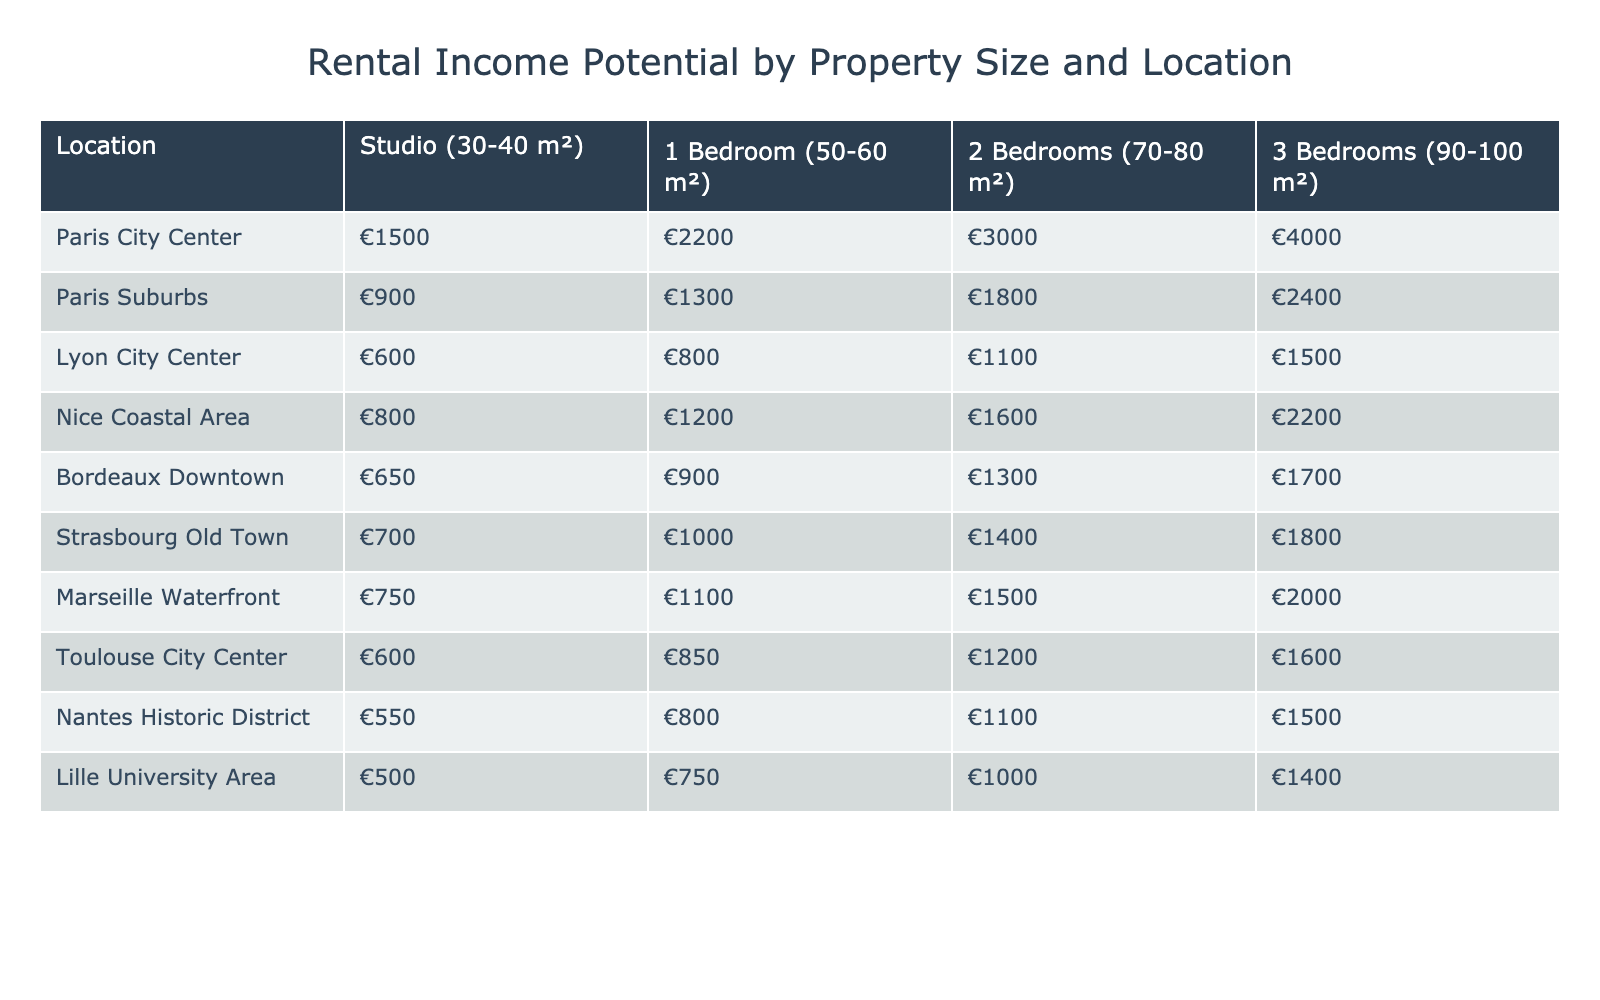What is the rental income for a 2-bedroom property in Paris City Center? The table indicates that the rental income for a 2-bedroom property (70-80 m²) in Paris City Center is listed as €3000.
Answer: €3000 Which location offers the highest rental income for a 1-bedroom property? In the table, Paris City Center shows the highest rental income for a 1-bedroom property at €2200.
Answer: Paris City Center What is the average rental income for a studio across all locations? To find the average, we sum the studio rental incomes: €1500 + €900 + €600 + €800 + €650 + €700 + €750 + €600 + €550 + €500 = €7550. There are 10 locations, so we divide: €7550 / 10 = €755.
Answer: €755 Is the rental income for a 3-bedroom property in Lyon City Center higher than in Marseille Waterfront? The rental income for a 3-bedroom property in Lyon City Center is €1500 while in Marseille Waterfront it is €2000. Since €1500 < €2000, the statement is false.
Answer: No What is the difference in rental income between a 2-bedroom property in Nice Coastal Area and Bordeaux Downtown? The rental income for a 2-bedroom in Nice Coastal Area is €1600, and in Bordeaux Downtown it is €1300. The difference is €1600 - €1300 = €300.
Answer: €300 Which type of property in Lille University Area has the lowest rental income? Looking at the table, the rental income for a studio in Lille University Area is €500, which is less than any other property type listed for that location.
Answer: Studio If a couple wants to invest in a studio in the suburban area of Paris, what will be their total costs for renting over a year? The rental income for a studio in Paris Suburbs is €900 per month. Over a year (12 months), the total would be €900 * 12 = €10,800.
Answer: €10,800 Which two locations have the same rental income for a 3-bedroom property? The table shows that both Bordeaux Downtown and Strasbourg Old Town have the same rental income of €1700 for a 3-bedroom property.
Answer: Bordeaux Downtown and Strasbourg Old Town How much more does a 1-bedroom property cost in Paris City Center compared to Lyon City Center? The rental income for a 1-bedroom in Paris City Center is €2200, while in Lyon City Center it is €800. The difference is €2200 - €800 = €1400.
Answer: €1400 Are the rental incomes for 2-bedroom properties in the cities of Nice and Bordeaux the same? The rental income for a 2-bedroom property in Nice is €1600 and in Bordeaux, it is €1300. These values are not the same; hence, the answer is no.
Answer: No 